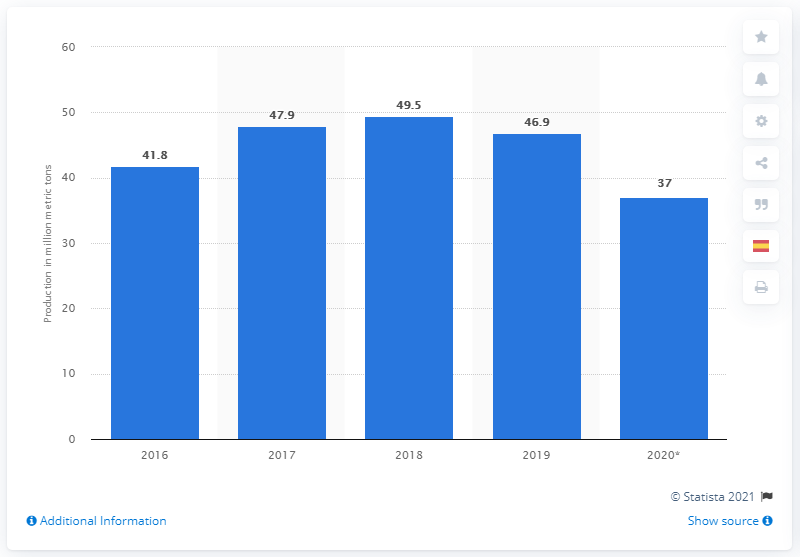Highlight a few significant elements in this photo. In 2020, the United States produced approximately 37 million metric tons of iron ore. 